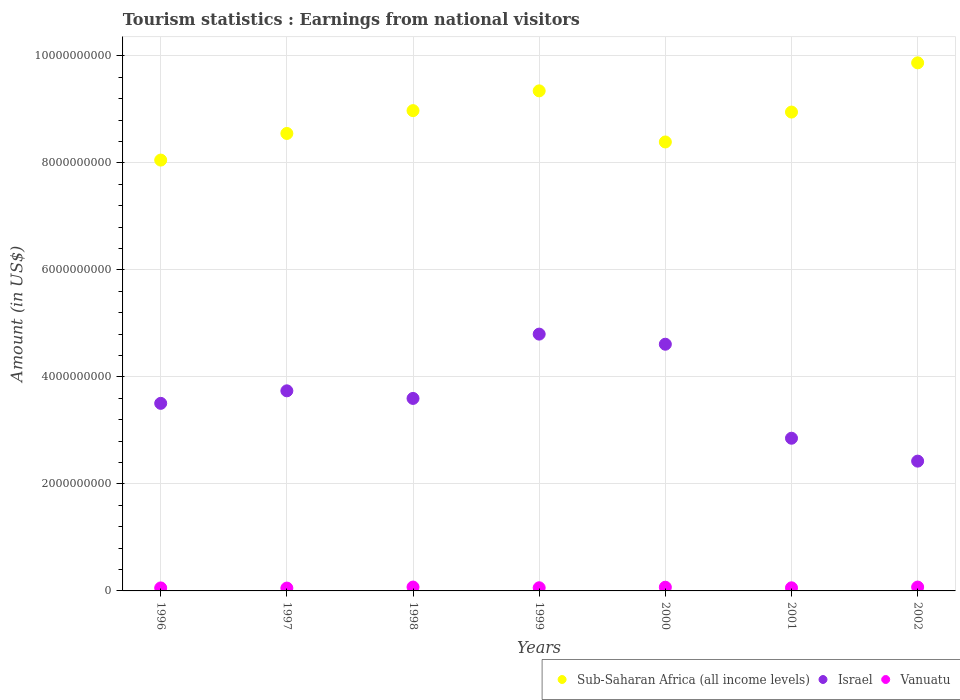Is the number of dotlines equal to the number of legend labels?
Keep it short and to the point. Yes. What is the earnings from national visitors in Israel in 1997?
Ensure brevity in your answer.  3.74e+09. Across all years, what is the maximum earnings from national visitors in Israel?
Offer a terse response. 4.80e+09. Across all years, what is the minimum earnings from national visitors in Sub-Saharan Africa (all income levels)?
Your response must be concise. 8.05e+09. In which year was the earnings from national visitors in Vanuatu maximum?
Your answer should be very brief. 1998. In which year was the earnings from national visitors in Vanuatu minimum?
Give a very brief answer. 1997. What is the total earnings from national visitors in Vanuatu in the graph?
Give a very brief answer. 4.39e+08. What is the difference between the earnings from national visitors in Israel in 1999 and that in 2001?
Provide a short and direct response. 1.95e+09. What is the difference between the earnings from national visitors in Vanuatu in 1997 and the earnings from national visitors in Sub-Saharan Africa (all income levels) in 2001?
Offer a very short reply. -8.90e+09. What is the average earnings from national visitors in Vanuatu per year?
Offer a terse response. 6.27e+07. In the year 1997, what is the difference between the earnings from national visitors in Israel and earnings from national visitors in Sub-Saharan Africa (all income levels)?
Offer a terse response. -4.81e+09. What is the ratio of the earnings from national visitors in Israel in 1997 to that in 2000?
Provide a succinct answer. 0.81. Is the difference between the earnings from national visitors in Israel in 1998 and 2002 greater than the difference between the earnings from national visitors in Sub-Saharan Africa (all income levels) in 1998 and 2002?
Provide a succinct answer. Yes. What is the difference between the highest and the lowest earnings from national visitors in Israel?
Offer a very short reply. 2.37e+09. Is the sum of the earnings from national visitors in Sub-Saharan Africa (all income levels) in 1997 and 2001 greater than the maximum earnings from national visitors in Vanuatu across all years?
Offer a terse response. Yes. Is it the case that in every year, the sum of the earnings from national visitors in Vanuatu and earnings from national visitors in Sub-Saharan Africa (all income levels)  is greater than the earnings from national visitors in Israel?
Provide a short and direct response. Yes. Does the earnings from national visitors in Sub-Saharan Africa (all income levels) monotonically increase over the years?
Your answer should be compact. No. Is the earnings from national visitors in Vanuatu strictly greater than the earnings from national visitors in Sub-Saharan Africa (all income levels) over the years?
Provide a short and direct response. No. What is the difference between two consecutive major ticks on the Y-axis?
Your response must be concise. 2.00e+09. Does the graph contain any zero values?
Your answer should be compact. No. How many legend labels are there?
Your answer should be compact. 3. What is the title of the graph?
Your response must be concise. Tourism statistics : Earnings from national visitors. What is the label or title of the X-axis?
Keep it short and to the point. Years. What is the label or title of the Y-axis?
Provide a short and direct response. Amount (in US$). What is the Amount (in US$) in Sub-Saharan Africa (all income levels) in 1996?
Make the answer very short. 8.05e+09. What is the Amount (in US$) in Israel in 1996?
Your answer should be very brief. 3.51e+09. What is the Amount (in US$) of Vanuatu in 1996?
Make the answer very short. 5.60e+07. What is the Amount (in US$) of Sub-Saharan Africa (all income levels) in 1997?
Provide a short and direct response. 8.55e+09. What is the Amount (in US$) in Israel in 1997?
Your answer should be compact. 3.74e+09. What is the Amount (in US$) of Vanuatu in 1997?
Offer a very short reply. 5.30e+07. What is the Amount (in US$) of Sub-Saharan Africa (all income levels) in 1998?
Your answer should be compact. 8.98e+09. What is the Amount (in US$) of Israel in 1998?
Your answer should be very brief. 3.60e+09. What is the Amount (in US$) in Vanuatu in 1998?
Your response must be concise. 7.20e+07. What is the Amount (in US$) of Sub-Saharan Africa (all income levels) in 1999?
Your answer should be very brief. 9.35e+09. What is the Amount (in US$) in Israel in 1999?
Offer a terse response. 4.80e+09. What is the Amount (in US$) in Vanuatu in 1999?
Ensure brevity in your answer.  5.90e+07. What is the Amount (in US$) in Sub-Saharan Africa (all income levels) in 2000?
Your response must be concise. 8.39e+09. What is the Amount (in US$) of Israel in 2000?
Give a very brief answer. 4.61e+09. What is the Amount (in US$) of Vanuatu in 2000?
Offer a terse response. 6.90e+07. What is the Amount (in US$) in Sub-Saharan Africa (all income levels) in 2001?
Your response must be concise. 8.95e+09. What is the Amount (in US$) in Israel in 2001?
Ensure brevity in your answer.  2.85e+09. What is the Amount (in US$) in Vanuatu in 2001?
Ensure brevity in your answer.  5.80e+07. What is the Amount (in US$) of Sub-Saharan Africa (all income levels) in 2002?
Give a very brief answer. 9.87e+09. What is the Amount (in US$) in Israel in 2002?
Your answer should be very brief. 2.43e+09. What is the Amount (in US$) of Vanuatu in 2002?
Ensure brevity in your answer.  7.20e+07. Across all years, what is the maximum Amount (in US$) in Sub-Saharan Africa (all income levels)?
Your response must be concise. 9.87e+09. Across all years, what is the maximum Amount (in US$) in Israel?
Make the answer very short. 4.80e+09. Across all years, what is the maximum Amount (in US$) in Vanuatu?
Give a very brief answer. 7.20e+07. Across all years, what is the minimum Amount (in US$) in Sub-Saharan Africa (all income levels)?
Offer a very short reply. 8.05e+09. Across all years, what is the minimum Amount (in US$) of Israel?
Provide a succinct answer. 2.43e+09. Across all years, what is the minimum Amount (in US$) in Vanuatu?
Make the answer very short. 5.30e+07. What is the total Amount (in US$) of Sub-Saharan Africa (all income levels) in the graph?
Provide a succinct answer. 6.21e+1. What is the total Amount (in US$) in Israel in the graph?
Ensure brevity in your answer.  2.55e+1. What is the total Amount (in US$) of Vanuatu in the graph?
Your response must be concise. 4.39e+08. What is the difference between the Amount (in US$) in Sub-Saharan Africa (all income levels) in 1996 and that in 1997?
Ensure brevity in your answer.  -4.98e+08. What is the difference between the Amount (in US$) of Israel in 1996 and that in 1997?
Your answer should be very brief. -2.34e+08. What is the difference between the Amount (in US$) of Sub-Saharan Africa (all income levels) in 1996 and that in 1998?
Your answer should be very brief. -9.24e+08. What is the difference between the Amount (in US$) of Israel in 1996 and that in 1998?
Keep it short and to the point. -9.20e+07. What is the difference between the Amount (in US$) in Vanuatu in 1996 and that in 1998?
Your answer should be very brief. -1.60e+07. What is the difference between the Amount (in US$) in Sub-Saharan Africa (all income levels) in 1996 and that in 1999?
Ensure brevity in your answer.  -1.29e+09. What is the difference between the Amount (in US$) in Israel in 1996 and that in 1999?
Ensure brevity in your answer.  -1.29e+09. What is the difference between the Amount (in US$) in Sub-Saharan Africa (all income levels) in 1996 and that in 2000?
Your answer should be compact. -3.39e+08. What is the difference between the Amount (in US$) in Israel in 1996 and that in 2000?
Offer a terse response. -1.10e+09. What is the difference between the Amount (in US$) of Vanuatu in 1996 and that in 2000?
Your answer should be very brief. -1.30e+07. What is the difference between the Amount (in US$) of Sub-Saharan Africa (all income levels) in 1996 and that in 2001?
Your answer should be very brief. -8.97e+08. What is the difference between the Amount (in US$) in Israel in 1996 and that in 2001?
Your answer should be compact. 6.52e+08. What is the difference between the Amount (in US$) in Sub-Saharan Africa (all income levels) in 1996 and that in 2002?
Offer a very short reply. -1.82e+09. What is the difference between the Amount (in US$) of Israel in 1996 and that in 2002?
Give a very brief answer. 1.08e+09. What is the difference between the Amount (in US$) in Vanuatu in 1996 and that in 2002?
Your answer should be very brief. -1.60e+07. What is the difference between the Amount (in US$) of Sub-Saharan Africa (all income levels) in 1997 and that in 1998?
Your answer should be very brief. -4.27e+08. What is the difference between the Amount (in US$) of Israel in 1997 and that in 1998?
Keep it short and to the point. 1.42e+08. What is the difference between the Amount (in US$) in Vanuatu in 1997 and that in 1998?
Provide a succinct answer. -1.90e+07. What is the difference between the Amount (in US$) in Sub-Saharan Africa (all income levels) in 1997 and that in 1999?
Offer a terse response. -7.96e+08. What is the difference between the Amount (in US$) in Israel in 1997 and that in 1999?
Keep it short and to the point. -1.06e+09. What is the difference between the Amount (in US$) in Vanuatu in 1997 and that in 1999?
Offer a very short reply. -6.00e+06. What is the difference between the Amount (in US$) of Sub-Saharan Africa (all income levels) in 1997 and that in 2000?
Provide a short and direct response. 1.59e+08. What is the difference between the Amount (in US$) of Israel in 1997 and that in 2000?
Your answer should be very brief. -8.71e+08. What is the difference between the Amount (in US$) in Vanuatu in 1997 and that in 2000?
Offer a terse response. -1.60e+07. What is the difference between the Amount (in US$) of Sub-Saharan Africa (all income levels) in 1997 and that in 2001?
Keep it short and to the point. -4.00e+08. What is the difference between the Amount (in US$) of Israel in 1997 and that in 2001?
Your response must be concise. 8.86e+08. What is the difference between the Amount (in US$) in Vanuatu in 1997 and that in 2001?
Provide a short and direct response. -5.00e+06. What is the difference between the Amount (in US$) in Sub-Saharan Africa (all income levels) in 1997 and that in 2002?
Offer a very short reply. -1.32e+09. What is the difference between the Amount (in US$) of Israel in 1997 and that in 2002?
Provide a succinct answer. 1.31e+09. What is the difference between the Amount (in US$) in Vanuatu in 1997 and that in 2002?
Provide a short and direct response. -1.90e+07. What is the difference between the Amount (in US$) in Sub-Saharan Africa (all income levels) in 1998 and that in 1999?
Your response must be concise. -3.69e+08. What is the difference between the Amount (in US$) of Israel in 1998 and that in 1999?
Keep it short and to the point. -1.20e+09. What is the difference between the Amount (in US$) of Vanuatu in 1998 and that in 1999?
Your response must be concise. 1.30e+07. What is the difference between the Amount (in US$) in Sub-Saharan Africa (all income levels) in 1998 and that in 2000?
Keep it short and to the point. 5.86e+08. What is the difference between the Amount (in US$) in Israel in 1998 and that in 2000?
Offer a terse response. -1.01e+09. What is the difference between the Amount (in US$) in Sub-Saharan Africa (all income levels) in 1998 and that in 2001?
Keep it short and to the point. 2.70e+07. What is the difference between the Amount (in US$) of Israel in 1998 and that in 2001?
Keep it short and to the point. 7.44e+08. What is the difference between the Amount (in US$) in Vanuatu in 1998 and that in 2001?
Your answer should be compact. 1.40e+07. What is the difference between the Amount (in US$) of Sub-Saharan Africa (all income levels) in 1998 and that in 2002?
Provide a short and direct response. -8.93e+08. What is the difference between the Amount (in US$) in Israel in 1998 and that in 2002?
Make the answer very short. 1.17e+09. What is the difference between the Amount (in US$) of Sub-Saharan Africa (all income levels) in 1999 and that in 2000?
Keep it short and to the point. 9.55e+08. What is the difference between the Amount (in US$) of Israel in 1999 and that in 2000?
Provide a succinct answer. 1.89e+08. What is the difference between the Amount (in US$) of Vanuatu in 1999 and that in 2000?
Offer a very short reply. -1.00e+07. What is the difference between the Amount (in US$) in Sub-Saharan Africa (all income levels) in 1999 and that in 2001?
Make the answer very short. 3.96e+08. What is the difference between the Amount (in US$) in Israel in 1999 and that in 2001?
Offer a terse response. 1.95e+09. What is the difference between the Amount (in US$) in Sub-Saharan Africa (all income levels) in 1999 and that in 2002?
Provide a succinct answer. -5.24e+08. What is the difference between the Amount (in US$) of Israel in 1999 and that in 2002?
Ensure brevity in your answer.  2.37e+09. What is the difference between the Amount (in US$) of Vanuatu in 1999 and that in 2002?
Your response must be concise. -1.30e+07. What is the difference between the Amount (in US$) in Sub-Saharan Africa (all income levels) in 2000 and that in 2001?
Give a very brief answer. -5.59e+08. What is the difference between the Amount (in US$) in Israel in 2000 and that in 2001?
Ensure brevity in your answer.  1.76e+09. What is the difference between the Amount (in US$) of Vanuatu in 2000 and that in 2001?
Your answer should be compact. 1.10e+07. What is the difference between the Amount (in US$) of Sub-Saharan Africa (all income levels) in 2000 and that in 2002?
Make the answer very short. -1.48e+09. What is the difference between the Amount (in US$) in Israel in 2000 and that in 2002?
Make the answer very short. 2.18e+09. What is the difference between the Amount (in US$) in Sub-Saharan Africa (all income levels) in 2001 and that in 2002?
Ensure brevity in your answer.  -9.20e+08. What is the difference between the Amount (in US$) of Israel in 2001 and that in 2002?
Make the answer very short. 4.28e+08. What is the difference between the Amount (in US$) of Vanuatu in 2001 and that in 2002?
Ensure brevity in your answer.  -1.40e+07. What is the difference between the Amount (in US$) of Sub-Saharan Africa (all income levels) in 1996 and the Amount (in US$) of Israel in 1997?
Offer a terse response. 4.31e+09. What is the difference between the Amount (in US$) of Sub-Saharan Africa (all income levels) in 1996 and the Amount (in US$) of Vanuatu in 1997?
Ensure brevity in your answer.  8.00e+09. What is the difference between the Amount (in US$) of Israel in 1996 and the Amount (in US$) of Vanuatu in 1997?
Provide a short and direct response. 3.45e+09. What is the difference between the Amount (in US$) in Sub-Saharan Africa (all income levels) in 1996 and the Amount (in US$) in Israel in 1998?
Keep it short and to the point. 4.45e+09. What is the difference between the Amount (in US$) of Sub-Saharan Africa (all income levels) in 1996 and the Amount (in US$) of Vanuatu in 1998?
Give a very brief answer. 7.98e+09. What is the difference between the Amount (in US$) in Israel in 1996 and the Amount (in US$) in Vanuatu in 1998?
Provide a short and direct response. 3.43e+09. What is the difference between the Amount (in US$) of Sub-Saharan Africa (all income levels) in 1996 and the Amount (in US$) of Israel in 1999?
Provide a succinct answer. 3.25e+09. What is the difference between the Amount (in US$) in Sub-Saharan Africa (all income levels) in 1996 and the Amount (in US$) in Vanuatu in 1999?
Your response must be concise. 7.99e+09. What is the difference between the Amount (in US$) in Israel in 1996 and the Amount (in US$) in Vanuatu in 1999?
Make the answer very short. 3.45e+09. What is the difference between the Amount (in US$) in Sub-Saharan Africa (all income levels) in 1996 and the Amount (in US$) in Israel in 2000?
Provide a succinct answer. 3.44e+09. What is the difference between the Amount (in US$) of Sub-Saharan Africa (all income levels) in 1996 and the Amount (in US$) of Vanuatu in 2000?
Provide a succinct answer. 7.98e+09. What is the difference between the Amount (in US$) in Israel in 1996 and the Amount (in US$) in Vanuatu in 2000?
Your answer should be compact. 3.44e+09. What is the difference between the Amount (in US$) in Sub-Saharan Africa (all income levels) in 1996 and the Amount (in US$) in Israel in 2001?
Offer a very short reply. 5.20e+09. What is the difference between the Amount (in US$) of Sub-Saharan Africa (all income levels) in 1996 and the Amount (in US$) of Vanuatu in 2001?
Keep it short and to the point. 7.99e+09. What is the difference between the Amount (in US$) of Israel in 1996 and the Amount (in US$) of Vanuatu in 2001?
Offer a very short reply. 3.45e+09. What is the difference between the Amount (in US$) in Sub-Saharan Africa (all income levels) in 1996 and the Amount (in US$) in Israel in 2002?
Your response must be concise. 5.63e+09. What is the difference between the Amount (in US$) of Sub-Saharan Africa (all income levels) in 1996 and the Amount (in US$) of Vanuatu in 2002?
Give a very brief answer. 7.98e+09. What is the difference between the Amount (in US$) of Israel in 1996 and the Amount (in US$) of Vanuatu in 2002?
Provide a short and direct response. 3.43e+09. What is the difference between the Amount (in US$) of Sub-Saharan Africa (all income levels) in 1997 and the Amount (in US$) of Israel in 1998?
Provide a succinct answer. 4.95e+09. What is the difference between the Amount (in US$) of Sub-Saharan Africa (all income levels) in 1997 and the Amount (in US$) of Vanuatu in 1998?
Provide a short and direct response. 8.48e+09. What is the difference between the Amount (in US$) of Israel in 1997 and the Amount (in US$) of Vanuatu in 1998?
Provide a succinct answer. 3.67e+09. What is the difference between the Amount (in US$) of Sub-Saharan Africa (all income levels) in 1997 and the Amount (in US$) of Israel in 1999?
Give a very brief answer. 3.75e+09. What is the difference between the Amount (in US$) in Sub-Saharan Africa (all income levels) in 1997 and the Amount (in US$) in Vanuatu in 1999?
Keep it short and to the point. 8.49e+09. What is the difference between the Amount (in US$) of Israel in 1997 and the Amount (in US$) of Vanuatu in 1999?
Give a very brief answer. 3.68e+09. What is the difference between the Amount (in US$) in Sub-Saharan Africa (all income levels) in 1997 and the Amount (in US$) in Israel in 2000?
Your answer should be compact. 3.94e+09. What is the difference between the Amount (in US$) in Sub-Saharan Africa (all income levels) in 1997 and the Amount (in US$) in Vanuatu in 2000?
Your answer should be compact. 8.48e+09. What is the difference between the Amount (in US$) in Israel in 1997 and the Amount (in US$) in Vanuatu in 2000?
Make the answer very short. 3.67e+09. What is the difference between the Amount (in US$) in Sub-Saharan Africa (all income levels) in 1997 and the Amount (in US$) in Israel in 2001?
Keep it short and to the point. 5.70e+09. What is the difference between the Amount (in US$) in Sub-Saharan Africa (all income levels) in 1997 and the Amount (in US$) in Vanuatu in 2001?
Your response must be concise. 8.49e+09. What is the difference between the Amount (in US$) in Israel in 1997 and the Amount (in US$) in Vanuatu in 2001?
Give a very brief answer. 3.68e+09. What is the difference between the Amount (in US$) in Sub-Saharan Africa (all income levels) in 1997 and the Amount (in US$) in Israel in 2002?
Your response must be concise. 6.12e+09. What is the difference between the Amount (in US$) of Sub-Saharan Africa (all income levels) in 1997 and the Amount (in US$) of Vanuatu in 2002?
Provide a succinct answer. 8.48e+09. What is the difference between the Amount (in US$) in Israel in 1997 and the Amount (in US$) in Vanuatu in 2002?
Offer a terse response. 3.67e+09. What is the difference between the Amount (in US$) of Sub-Saharan Africa (all income levels) in 1998 and the Amount (in US$) of Israel in 1999?
Offer a very short reply. 4.18e+09. What is the difference between the Amount (in US$) of Sub-Saharan Africa (all income levels) in 1998 and the Amount (in US$) of Vanuatu in 1999?
Your response must be concise. 8.92e+09. What is the difference between the Amount (in US$) in Israel in 1998 and the Amount (in US$) in Vanuatu in 1999?
Offer a terse response. 3.54e+09. What is the difference between the Amount (in US$) in Sub-Saharan Africa (all income levels) in 1998 and the Amount (in US$) in Israel in 2000?
Ensure brevity in your answer.  4.37e+09. What is the difference between the Amount (in US$) of Sub-Saharan Africa (all income levels) in 1998 and the Amount (in US$) of Vanuatu in 2000?
Offer a very short reply. 8.91e+09. What is the difference between the Amount (in US$) in Israel in 1998 and the Amount (in US$) in Vanuatu in 2000?
Offer a terse response. 3.53e+09. What is the difference between the Amount (in US$) of Sub-Saharan Africa (all income levels) in 1998 and the Amount (in US$) of Israel in 2001?
Your response must be concise. 6.12e+09. What is the difference between the Amount (in US$) in Sub-Saharan Africa (all income levels) in 1998 and the Amount (in US$) in Vanuatu in 2001?
Give a very brief answer. 8.92e+09. What is the difference between the Amount (in US$) of Israel in 1998 and the Amount (in US$) of Vanuatu in 2001?
Ensure brevity in your answer.  3.54e+09. What is the difference between the Amount (in US$) of Sub-Saharan Africa (all income levels) in 1998 and the Amount (in US$) of Israel in 2002?
Your answer should be compact. 6.55e+09. What is the difference between the Amount (in US$) in Sub-Saharan Africa (all income levels) in 1998 and the Amount (in US$) in Vanuatu in 2002?
Your answer should be very brief. 8.91e+09. What is the difference between the Amount (in US$) of Israel in 1998 and the Amount (in US$) of Vanuatu in 2002?
Your answer should be very brief. 3.53e+09. What is the difference between the Amount (in US$) of Sub-Saharan Africa (all income levels) in 1999 and the Amount (in US$) of Israel in 2000?
Your answer should be very brief. 4.74e+09. What is the difference between the Amount (in US$) in Sub-Saharan Africa (all income levels) in 1999 and the Amount (in US$) in Vanuatu in 2000?
Keep it short and to the point. 9.28e+09. What is the difference between the Amount (in US$) in Israel in 1999 and the Amount (in US$) in Vanuatu in 2000?
Keep it short and to the point. 4.73e+09. What is the difference between the Amount (in US$) in Sub-Saharan Africa (all income levels) in 1999 and the Amount (in US$) in Israel in 2001?
Your answer should be compact. 6.49e+09. What is the difference between the Amount (in US$) in Sub-Saharan Africa (all income levels) in 1999 and the Amount (in US$) in Vanuatu in 2001?
Provide a short and direct response. 9.29e+09. What is the difference between the Amount (in US$) in Israel in 1999 and the Amount (in US$) in Vanuatu in 2001?
Your answer should be very brief. 4.74e+09. What is the difference between the Amount (in US$) in Sub-Saharan Africa (all income levels) in 1999 and the Amount (in US$) in Israel in 2002?
Provide a succinct answer. 6.92e+09. What is the difference between the Amount (in US$) of Sub-Saharan Africa (all income levels) in 1999 and the Amount (in US$) of Vanuatu in 2002?
Give a very brief answer. 9.27e+09. What is the difference between the Amount (in US$) of Israel in 1999 and the Amount (in US$) of Vanuatu in 2002?
Your response must be concise. 4.73e+09. What is the difference between the Amount (in US$) in Sub-Saharan Africa (all income levels) in 2000 and the Amount (in US$) in Israel in 2001?
Make the answer very short. 5.54e+09. What is the difference between the Amount (in US$) in Sub-Saharan Africa (all income levels) in 2000 and the Amount (in US$) in Vanuatu in 2001?
Provide a short and direct response. 8.33e+09. What is the difference between the Amount (in US$) in Israel in 2000 and the Amount (in US$) in Vanuatu in 2001?
Offer a terse response. 4.55e+09. What is the difference between the Amount (in US$) in Sub-Saharan Africa (all income levels) in 2000 and the Amount (in US$) in Israel in 2002?
Offer a very short reply. 5.97e+09. What is the difference between the Amount (in US$) of Sub-Saharan Africa (all income levels) in 2000 and the Amount (in US$) of Vanuatu in 2002?
Offer a terse response. 8.32e+09. What is the difference between the Amount (in US$) of Israel in 2000 and the Amount (in US$) of Vanuatu in 2002?
Make the answer very short. 4.54e+09. What is the difference between the Amount (in US$) in Sub-Saharan Africa (all income levels) in 2001 and the Amount (in US$) in Israel in 2002?
Offer a very short reply. 6.52e+09. What is the difference between the Amount (in US$) of Sub-Saharan Africa (all income levels) in 2001 and the Amount (in US$) of Vanuatu in 2002?
Give a very brief answer. 8.88e+09. What is the difference between the Amount (in US$) in Israel in 2001 and the Amount (in US$) in Vanuatu in 2002?
Ensure brevity in your answer.  2.78e+09. What is the average Amount (in US$) of Sub-Saharan Africa (all income levels) per year?
Make the answer very short. 8.88e+09. What is the average Amount (in US$) in Israel per year?
Give a very brief answer. 3.65e+09. What is the average Amount (in US$) in Vanuatu per year?
Your answer should be very brief. 6.27e+07. In the year 1996, what is the difference between the Amount (in US$) of Sub-Saharan Africa (all income levels) and Amount (in US$) of Israel?
Your answer should be compact. 4.55e+09. In the year 1996, what is the difference between the Amount (in US$) in Sub-Saharan Africa (all income levels) and Amount (in US$) in Vanuatu?
Keep it short and to the point. 8.00e+09. In the year 1996, what is the difference between the Amount (in US$) in Israel and Amount (in US$) in Vanuatu?
Keep it short and to the point. 3.45e+09. In the year 1997, what is the difference between the Amount (in US$) of Sub-Saharan Africa (all income levels) and Amount (in US$) of Israel?
Ensure brevity in your answer.  4.81e+09. In the year 1997, what is the difference between the Amount (in US$) of Sub-Saharan Africa (all income levels) and Amount (in US$) of Vanuatu?
Your answer should be compact. 8.50e+09. In the year 1997, what is the difference between the Amount (in US$) of Israel and Amount (in US$) of Vanuatu?
Ensure brevity in your answer.  3.69e+09. In the year 1998, what is the difference between the Amount (in US$) in Sub-Saharan Africa (all income levels) and Amount (in US$) in Israel?
Your response must be concise. 5.38e+09. In the year 1998, what is the difference between the Amount (in US$) of Sub-Saharan Africa (all income levels) and Amount (in US$) of Vanuatu?
Make the answer very short. 8.91e+09. In the year 1998, what is the difference between the Amount (in US$) of Israel and Amount (in US$) of Vanuatu?
Provide a succinct answer. 3.53e+09. In the year 1999, what is the difference between the Amount (in US$) of Sub-Saharan Africa (all income levels) and Amount (in US$) of Israel?
Your response must be concise. 4.55e+09. In the year 1999, what is the difference between the Amount (in US$) in Sub-Saharan Africa (all income levels) and Amount (in US$) in Vanuatu?
Give a very brief answer. 9.29e+09. In the year 1999, what is the difference between the Amount (in US$) of Israel and Amount (in US$) of Vanuatu?
Offer a terse response. 4.74e+09. In the year 2000, what is the difference between the Amount (in US$) in Sub-Saharan Africa (all income levels) and Amount (in US$) in Israel?
Give a very brief answer. 3.78e+09. In the year 2000, what is the difference between the Amount (in US$) of Sub-Saharan Africa (all income levels) and Amount (in US$) of Vanuatu?
Your answer should be very brief. 8.32e+09. In the year 2000, what is the difference between the Amount (in US$) in Israel and Amount (in US$) in Vanuatu?
Your answer should be compact. 4.54e+09. In the year 2001, what is the difference between the Amount (in US$) of Sub-Saharan Africa (all income levels) and Amount (in US$) of Israel?
Your answer should be compact. 6.10e+09. In the year 2001, what is the difference between the Amount (in US$) in Sub-Saharan Africa (all income levels) and Amount (in US$) in Vanuatu?
Ensure brevity in your answer.  8.89e+09. In the year 2001, what is the difference between the Amount (in US$) in Israel and Amount (in US$) in Vanuatu?
Provide a short and direct response. 2.80e+09. In the year 2002, what is the difference between the Amount (in US$) of Sub-Saharan Africa (all income levels) and Amount (in US$) of Israel?
Your response must be concise. 7.44e+09. In the year 2002, what is the difference between the Amount (in US$) in Sub-Saharan Africa (all income levels) and Amount (in US$) in Vanuatu?
Provide a succinct answer. 9.80e+09. In the year 2002, what is the difference between the Amount (in US$) in Israel and Amount (in US$) in Vanuatu?
Ensure brevity in your answer.  2.35e+09. What is the ratio of the Amount (in US$) of Sub-Saharan Africa (all income levels) in 1996 to that in 1997?
Make the answer very short. 0.94. What is the ratio of the Amount (in US$) of Israel in 1996 to that in 1997?
Your response must be concise. 0.94. What is the ratio of the Amount (in US$) in Vanuatu in 1996 to that in 1997?
Offer a very short reply. 1.06. What is the ratio of the Amount (in US$) of Sub-Saharan Africa (all income levels) in 1996 to that in 1998?
Your answer should be very brief. 0.9. What is the ratio of the Amount (in US$) in Israel in 1996 to that in 1998?
Offer a terse response. 0.97. What is the ratio of the Amount (in US$) of Sub-Saharan Africa (all income levels) in 1996 to that in 1999?
Ensure brevity in your answer.  0.86. What is the ratio of the Amount (in US$) of Israel in 1996 to that in 1999?
Provide a succinct answer. 0.73. What is the ratio of the Amount (in US$) in Vanuatu in 1996 to that in 1999?
Give a very brief answer. 0.95. What is the ratio of the Amount (in US$) of Sub-Saharan Africa (all income levels) in 1996 to that in 2000?
Give a very brief answer. 0.96. What is the ratio of the Amount (in US$) of Israel in 1996 to that in 2000?
Your response must be concise. 0.76. What is the ratio of the Amount (in US$) of Vanuatu in 1996 to that in 2000?
Your response must be concise. 0.81. What is the ratio of the Amount (in US$) of Sub-Saharan Africa (all income levels) in 1996 to that in 2001?
Ensure brevity in your answer.  0.9. What is the ratio of the Amount (in US$) of Israel in 1996 to that in 2001?
Make the answer very short. 1.23. What is the ratio of the Amount (in US$) of Vanuatu in 1996 to that in 2001?
Keep it short and to the point. 0.97. What is the ratio of the Amount (in US$) of Sub-Saharan Africa (all income levels) in 1996 to that in 2002?
Your answer should be very brief. 0.82. What is the ratio of the Amount (in US$) of Israel in 1996 to that in 2002?
Provide a succinct answer. 1.45. What is the ratio of the Amount (in US$) of Vanuatu in 1996 to that in 2002?
Keep it short and to the point. 0.78. What is the ratio of the Amount (in US$) in Sub-Saharan Africa (all income levels) in 1997 to that in 1998?
Make the answer very short. 0.95. What is the ratio of the Amount (in US$) in Israel in 1997 to that in 1998?
Make the answer very short. 1.04. What is the ratio of the Amount (in US$) in Vanuatu in 1997 to that in 1998?
Your answer should be very brief. 0.74. What is the ratio of the Amount (in US$) in Sub-Saharan Africa (all income levels) in 1997 to that in 1999?
Your answer should be very brief. 0.91. What is the ratio of the Amount (in US$) of Israel in 1997 to that in 1999?
Your response must be concise. 0.78. What is the ratio of the Amount (in US$) in Vanuatu in 1997 to that in 1999?
Offer a very short reply. 0.9. What is the ratio of the Amount (in US$) of Sub-Saharan Africa (all income levels) in 1997 to that in 2000?
Make the answer very short. 1.02. What is the ratio of the Amount (in US$) in Israel in 1997 to that in 2000?
Make the answer very short. 0.81. What is the ratio of the Amount (in US$) of Vanuatu in 1997 to that in 2000?
Ensure brevity in your answer.  0.77. What is the ratio of the Amount (in US$) of Sub-Saharan Africa (all income levels) in 1997 to that in 2001?
Give a very brief answer. 0.96. What is the ratio of the Amount (in US$) of Israel in 1997 to that in 2001?
Offer a very short reply. 1.31. What is the ratio of the Amount (in US$) in Vanuatu in 1997 to that in 2001?
Your answer should be compact. 0.91. What is the ratio of the Amount (in US$) in Sub-Saharan Africa (all income levels) in 1997 to that in 2002?
Give a very brief answer. 0.87. What is the ratio of the Amount (in US$) of Israel in 1997 to that in 2002?
Give a very brief answer. 1.54. What is the ratio of the Amount (in US$) in Vanuatu in 1997 to that in 2002?
Provide a succinct answer. 0.74. What is the ratio of the Amount (in US$) of Sub-Saharan Africa (all income levels) in 1998 to that in 1999?
Your answer should be compact. 0.96. What is the ratio of the Amount (in US$) in Israel in 1998 to that in 1999?
Your answer should be very brief. 0.75. What is the ratio of the Amount (in US$) in Vanuatu in 1998 to that in 1999?
Give a very brief answer. 1.22. What is the ratio of the Amount (in US$) of Sub-Saharan Africa (all income levels) in 1998 to that in 2000?
Ensure brevity in your answer.  1.07. What is the ratio of the Amount (in US$) of Israel in 1998 to that in 2000?
Your response must be concise. 0.78. What is the ratio of the Amount (in US$) of Vanuatu in 1998 to that in 2000?
Make the answer very short. 1.04. What is the ratio of the Amount (in US$) in Israel in 1998 to that in 2001?
Provide a short and direct response. 1.26. What is the ratio of the Amount (in US$) of Vanuatu in 1998 to that in 2001?
Keep it short and to the point. 1.24. What is the ratio of the Amount (in US$) of Sub-Saharan Africa (all income levels) in 1998 to that in 2002?
Provide a short and direct response. 0.91. What is the ratio of the Amount (in US$) in Israel in 1998 to that in 2002?
Your response must be concise. 1.48. What is the ratio of the Amount (in US$) in Vanuatu in 1998 to that in 2002?
Give a very brief answer. 1. What is the ratio of the Amount (in US$) of Sub-Saharan Africa (all income levels) in 1999 to that in 2000?
Your answer should be very brief. 1.11. What is the ratio of the Amount (in US$) of Israel in 1999 to that in 2000?
Make the answer very short. 1.04. What is the ratio of the Amount (in US$) of Vanuatu in 1999 to that in 2000?
Offer a terse response. 0.86. What is the ratio of the Amount (in US$) in Sub-Saharan Africa (all income levels) in 1999 to that in 2001?
Provide a succinct answer. 1.04. What is the ratio of the Amount (in US$) in Israel in 1999 to that in 2001?
Your answer should be compact. 1.68. What is the ratio of the Amount (in US$) in Vanuatu in 1999 to that in 2001?
Provide a succinct answer. 1.02. What is the ratio of the Amount (in US$) in Sub-Saharan Africa (all income levels) in 1999 to that in 2002?
Give a very brief answer. 0.95. What is the ratio of the Amount (in US$) in Israel in 1999 to that in 2002?
Your response must be concise. 1.98. What is the ratio of the Amount (in US$) in Vanuatu in 1999 to that in 2002?
Your answer should be very brief. 0.82. What is the ratio of the Amount (in US$) in Sub-Saharan Africa (all income levels) in 2000 to that in 2001?
Provide a succinct answer. 0.94. What is the ratio of the Amount (in US$) in Israel in 2000 to that in 2001?
Offer a terse response. 1.62. What is the ratio of the Amount (in US$) in Vanuatu in 2000 to that in 2001?
Your answer should be compact. 1.19. What is the ratio of the Amount (in US$) in Sub-Saharan Africa (all income levels) in 2000 to that in 2002?
Offer a terse response. 0.85. What is the ratio of the Amount (in US$) in Israel in 2000 to that in 2002?
Make the answer very short. 1.9. What is the ratio of the Amount (in US$) of Vanuatu in 2000 to that in 2002?
Your answer should be compact. 0.96. What is the ratio of the Amount (in US$) in Sub-Saharan Africa (all income levels) in 2001 to that in 2002?
Offer a terse response. 0.91. What is the ratio of the Amount (in US$) of Israel in 2001 to that in 2002?
Your answer should be very brief. 1.18. What is the ratio of the Amount (in US$) in Vanuatu in 2001 to that in 2002?
Provide a succinct answer. 0.81. What is the difference between the highest and the second highest Amount (in US$) of Sub-Saharan Africa (all income levels)?
Make the answer very short. 5.24e+08. What is the difference between the highest and the second highest Amount (in US$) in Israel?
Offer a very short reply. 1.89e+08. What is the difference between the highest and the lowest Amount (in US$) of Sub-Saharan Africa (all income levels)?
Keep it short and to the point. 1.82e+09. What is the difference between the highest and the lowest Amount (in US$) of Israel?
Give a very brief answer. 2.37e+09. What is the difference between the highest and the lowest Amount (in US$) in Vanuatu?
Keep it short and to the point. 1.90e+07. 